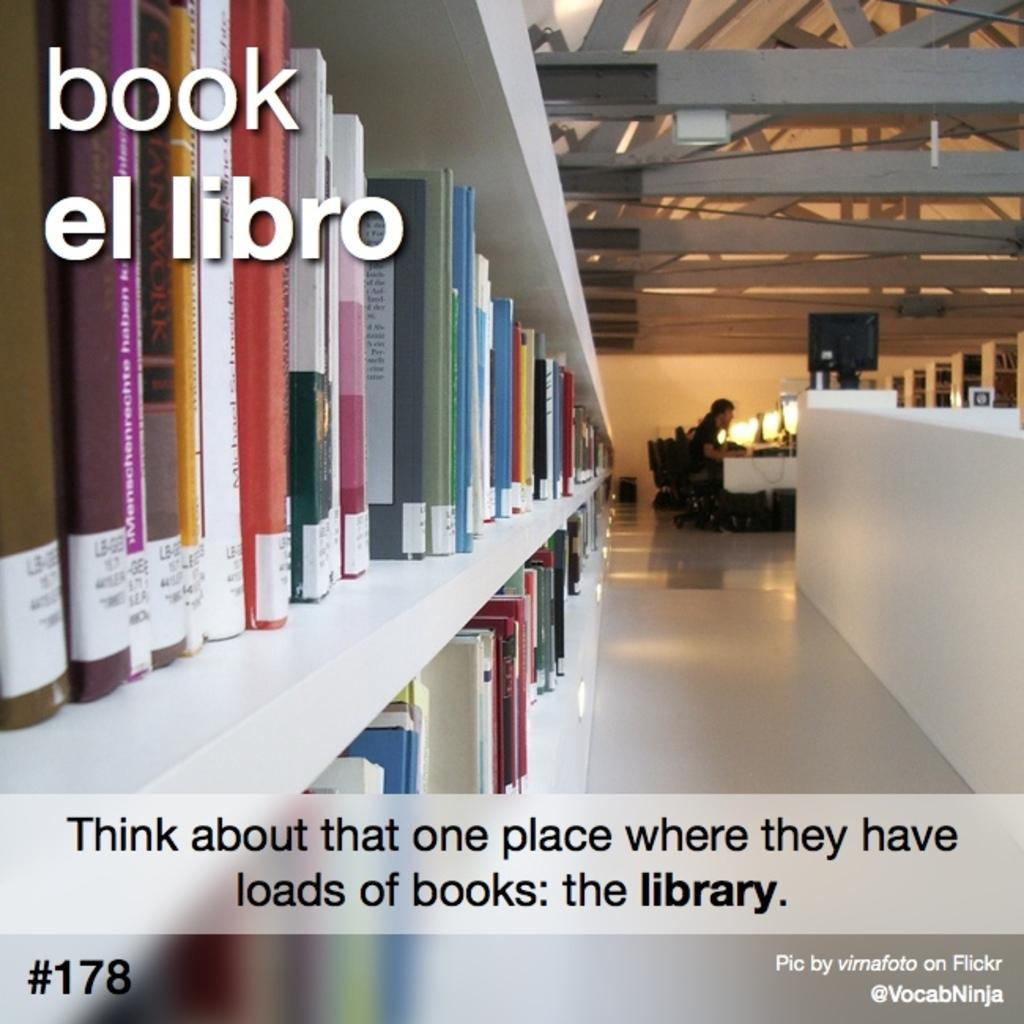<image>
Share a concise interpretation of the image provided. An advertisement for the library shows someone studying peacefully and a large selection of books. 